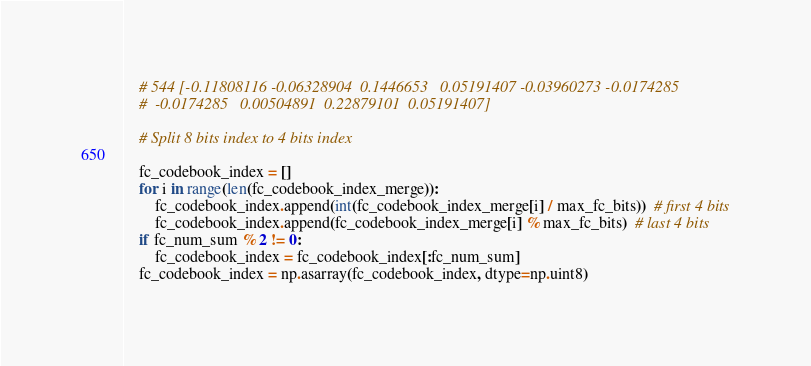<code> <loc_0><loc_0><loc_500><loc_500><_Python_>    # 544 [-0.11808116 -0.06328904  0.1446653   0.05191407 -0.03960273 -0.0174285
    #  -0.0174285   0.00504891  0.22879101  0.05191407]

    # Split 8 bits index to 4 bits index

    fc_codebook_index = []
    for i in range(len(fc_codebook_index_merge)):
        fc_codebook_index.append(int(fc_codebook_index_merge[i] / max_fc_bits))  # first 4 bits
        fc_codebook_index.append(fc_codebook_index_merge[i] % max_fc_bits)  # last 4 bits
    if fc_num_sum % 2 != 0:
        fc_codebook_index = fc_codebook_index[:fc_num_sum]
    fc_codebook_index = np.asarray(fc_codebook_index, dtype=np.uint8)
</code> 